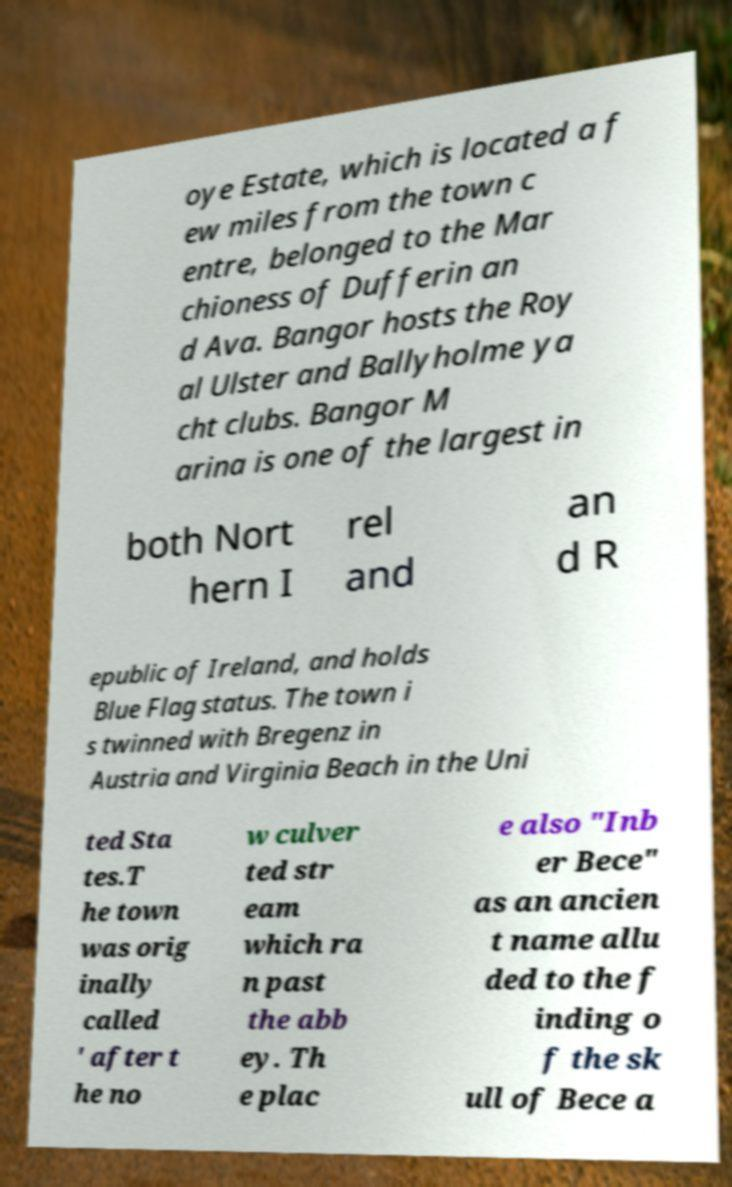Can you accurately transcribe the text from the provided image for me? oye Estate, which is located a f ew miles from the town c entre, belonged to the Mar chioness of Dufferin an d Ava. Bangor hosts the Roy al Ulster and Ballyholme ya cht clubs. Bangor M arina is one of the largest in both Nort hern I rel and an d R epublic of Ireland, and holds Blue Flag status. The town i s twinned with Bregenz in Austria and Virginia Beach in the Uni ted Sta tes.T he town was orig inally called ' after t he no w culver ted str eam which ra n past the abb ey. Th e plac e also "Inb er Bece" as an ancien t name allu ded to the f inding o f the sk ull of Bece a 